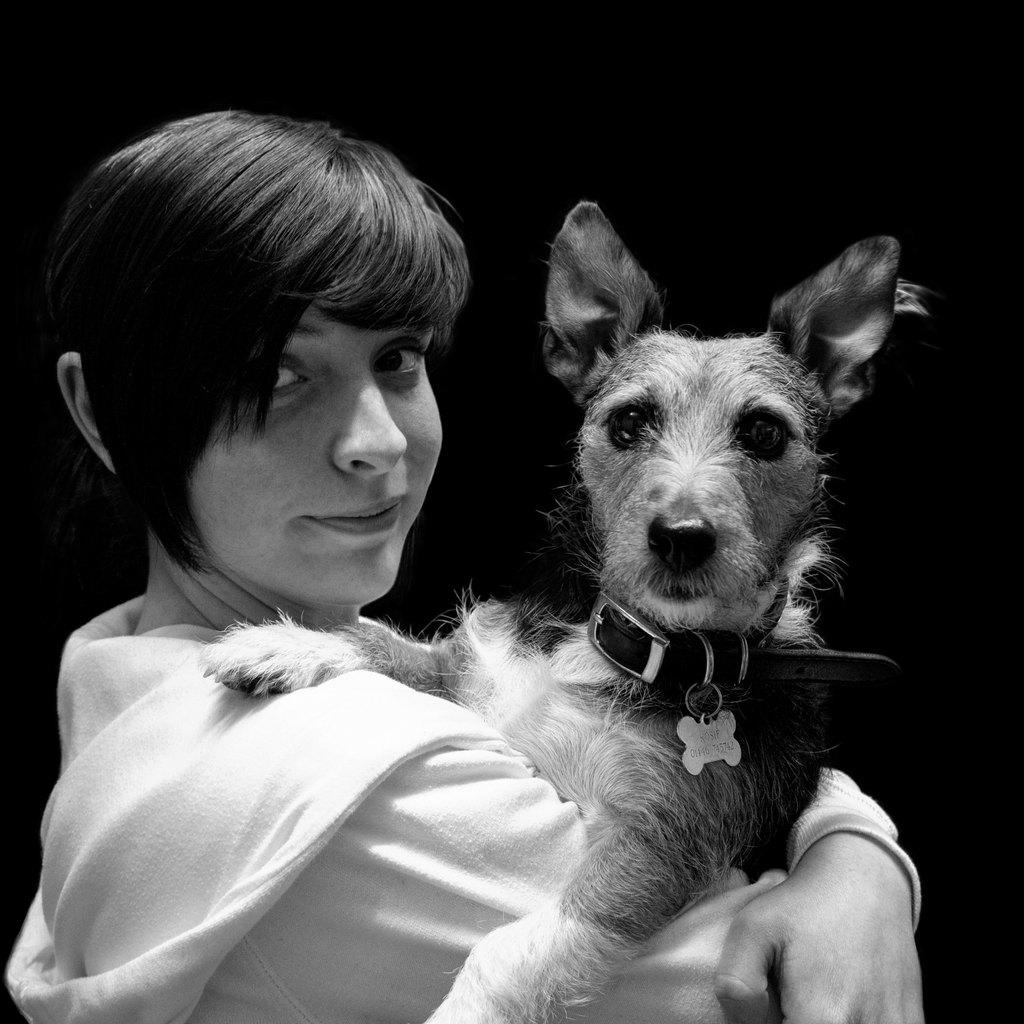What is the color scheme of the image? The image is black and white. Who is present in the image? There is a woman in the image. What is the woman holding in the image? The woman is holding a dog. What can be seen in the background of the image? The background of the image is black. What invention is the woman using to communicate with the dog in the image? There is no invention present in the image, and the woman is not using any device to communicate with the dog. 